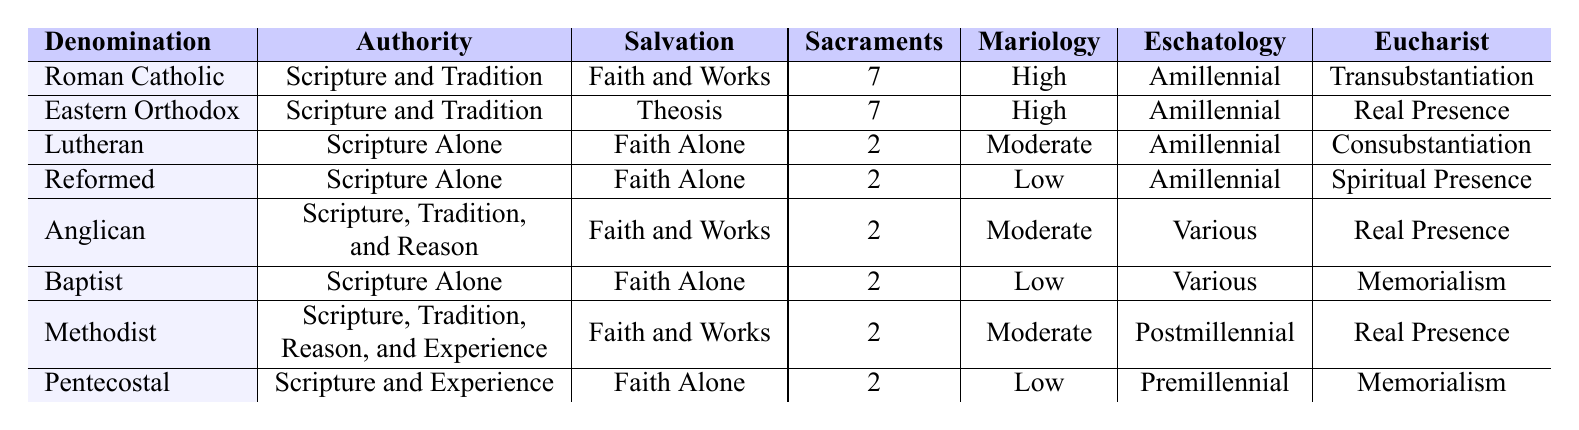What is the theological authority for the Lutheran denomination? The table shows that the Lutheran denomination has "Scripture Alone" as its authority.
Answer: Scripture Alone How many sacraments do the Eastern Orthodox Church recognize? According to the table, the Eastern Orthodox Church recognizes 7 sacraments.
Answer: 7 What is the view of the Eucharist in the Baptist denomination? The table indicates that the Baptist denomination's view of the Eucharist is "Memorialism."
Answer: Memorialism Do all denominations listed have the same view of eschatology? The table reveals that the eschatology varies among the denominations: Amillennial for Roman Catholic, Eastern Orthodox, Lutheran, and Reformed; Various for Anglican; Postmillennial for Methodist; and Premillennial for Pentecostal. Therefore, they do not share the same view.
Answer: No Which denomination has the highest influence score among theologians? By reviewing the table, the highest influence score of 10 is held by both Thomas Aquinas (Roman Catholic) and Martin Luther (Lutheran).
Answer: Roman Catholic and Lutheran How many denominations believe in "Faith Alone" as the means of salvation? The table shows that the Lutheran, Reformed, and Pentecostal denominations hold "Faith Alone" as their means of salvation. Counting these gives a total of three denominations.
Answer: 3 What is the average number of sacraments across all denominations? The total number of sacraments counted from the table is 7 (Roman Catholic) + 7 (Eastern Orthodox) + 2 (Lutheran) + 2 (Reformed) + 2 (Anglican) + 2 (Baptist) + 2 (Methodist) + 2 (Pentecostal) = 26. There are 8 denominations, so the average is 26 / 8 = 3.25.
Answer: 3.25 Which denominations have a high view of Mariology? From the table, the Roman Catholic and Eastern Orthodox denominations are classified as having a "High" view of Mariology.
Answer: Roman Catholic and Eastern Orthodox Is there any denomination that recognizes more than 2 sacraments? The Roman Catholic and Eastern Orthodox denominations each recognize 7 sacraments, so they do exceed 2 sacraments.
Answer: Yes Which theological view regarding salvation is unique to the Eastern Orthodox Church? The table indicates that the Eastern Orthodox Church has "Theosis" as its view of salvation, which is not mentioned for any other denomination.
Answer: Theosis 